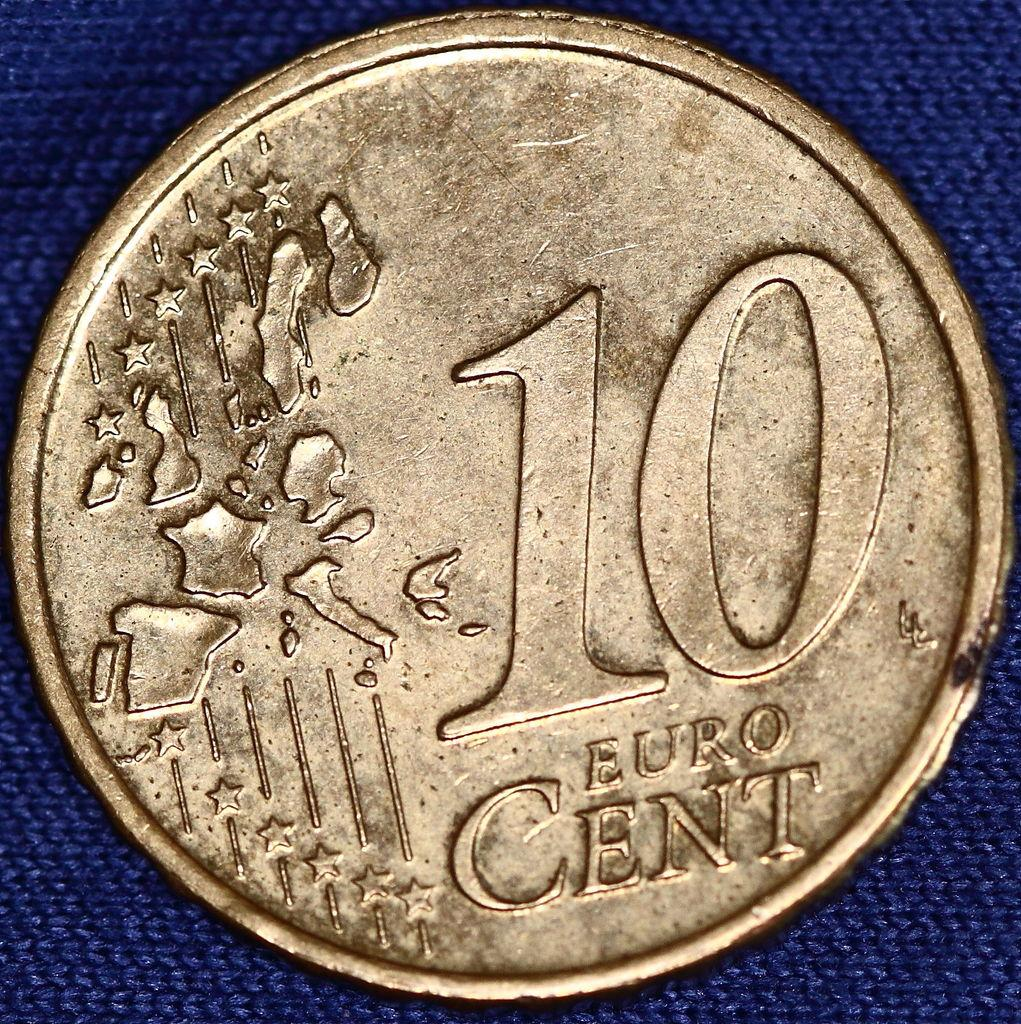<image>
Relay a brief, clear account of the picture shown. Round antique coin worth 10 Euro with a chip on the edge. 